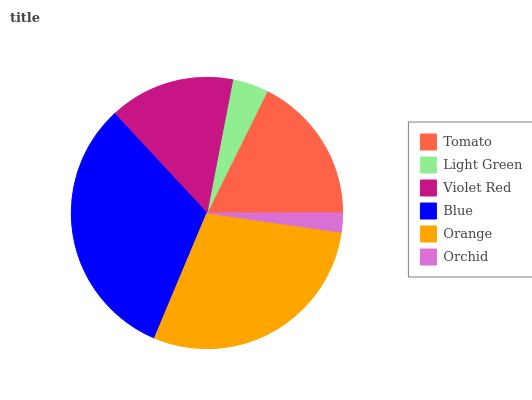Is Orchid the minimum?
Answer yes or no. Yes. Is Blue the maximum?
Answer yes or no. Yes. Is Light Green the minimum?
Answer yes or no. No. Is Light Green the maximum?
Answer yes or no. No. Is Tomato greater than Light Green?
Answer yes or no. Yes. Is Light Green less than Tomato?
Answer yes or no. Yes. Is Light Green greater than Tomato?
Answer yes or no. No. Is Tomato less than Light Green?
Answer yes or no. No. Is Tomato the high median?
Answer yes or no. Yes. Is Violet Red the low median?
Answer yes or no. Yes. Is Blue the high median?
Answer yes or no. No. Is Orchid the low median?
Answer yes or no. No. 